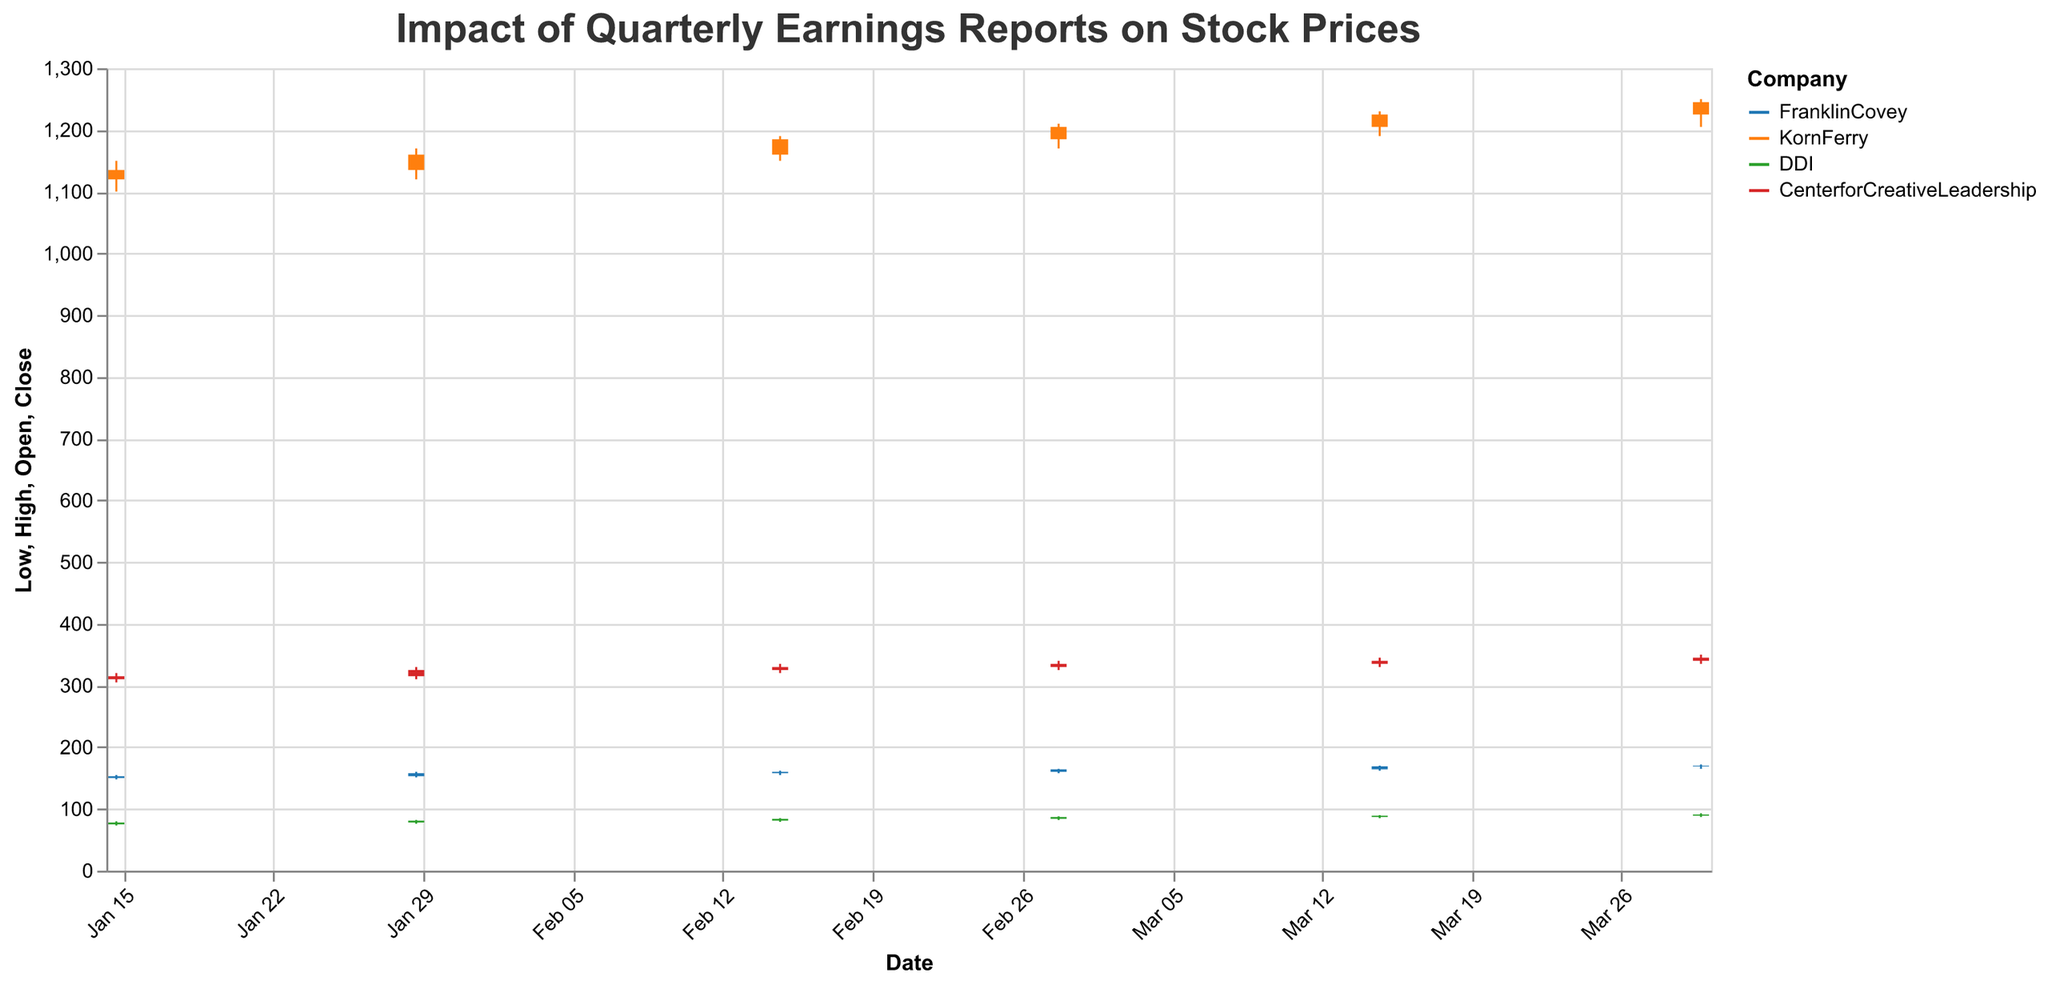What is the highest stock price recorded by DDI during the given period? The highest stock price is represented by the "High" value in the candlestick chart. For DDI, it reached its highest price of 93.00 on 2023-03-30.
Answer: 93.00 Which company had the highest closing price on 2023-02-28? To determine this, compare the "Close" values for all companies on 2023-02-28. FranklinCovey closed at 164.00, KornFerry at 1205.00, DDI at 87.00, and CenterforCreativeLeadership at 335.00. KornFerry had the highest closing price.
Answer: KornFerry How did the stock price of FranklinCovey change from 2023-02-28 to 2023-03-15? To examine the change, note the "Close" price on both dates. FranklinCovey closed at 164.00 on 2023-02-28 and at 169.00 on 2023-03-15. The stock increased by 5.00.
Answer: Increased by 5.00 What is the average closing price of CenterforCreativeLeadership across all given dates? Sum up the "Close" prices for all dates and divide by the number of dates. The closing prices are 315.00, 325.00, 330.00, 335.00, 340.00, and 345.00. The average is (315.00 + 325.00 + 330.00 + 335.00 + 340.00 + 345.00) / 6 = 331.67.
Answer: 331.67 Which company's stock showed the largest volume increase between 2023-01-15 and 2023-03-30? Compare the "Volume" for all companies on 2023-01-15 and 2023-03-30. FranklinCovey: 1200000 to 1450000; KornFerry: 2500000 to 3100000; DDI: 500000 to 850000; CenterforCreativeLeadership: 1300000 to 1550000. The largest increase (600000) is for KornFerry.
Answer: KornFerry How much higher was KornFerry's highest price on 2023-03-30 compared to FranklinCovey's highest price on the same date? KornFerry's highest price on 2023-03-30 is 1250.00, and FranklinCovey's highest price is 172.00. The difference is 1250.00 - 172.00 = 1078.00.
Answer: 1078.00 On which date did DDI's stock reach its highest closing value, and what was the value? Look for the highest "Close" value in DDI's data. It closed highest at 91.00 on 2023-03-30.
Answer: 2023-03-30, 91.00 Which company had the smallest range (difference between high and low) in stock prices on 2023-02-15? Calculate the range for each company's stock price on 2023-02-15. FranklinCovey: 162.00 - 155.00 = 7.00; KornFerry: 1190.00 - 1150.00 = 40.00; DDI: 85.00 - 79.00 = 6.00; CenterforCreativeLeadership: 335.00 - 320.00 = 15.00. DDI had the smallest range.
Answer: DDI What is the total volume of stocks traded for FranklinCovey across all dates in the dataset? Sum the "Volume" values for all dates for FranklinCovey. The volumes are 1200000, 1350000, 1400000, 1500000, 1600000, and 1450000. The total is 1200000 + 1350000 + 1400000 + 1500000 + 1600000 + 1450000 = 8500000.
Answer: 8500000 How did the stock opening price of KornFerry change between the first and last date? Check the "Open" price on 2023-01-15 and 2023-03-30 for KornFerry. The opening prices are 1120.00 on 2023-01-15 and 1225.00 on 2023-03-30. The change is 1225.00 - 1120.00 = 105.00.
Answer: Increased by 105.00 